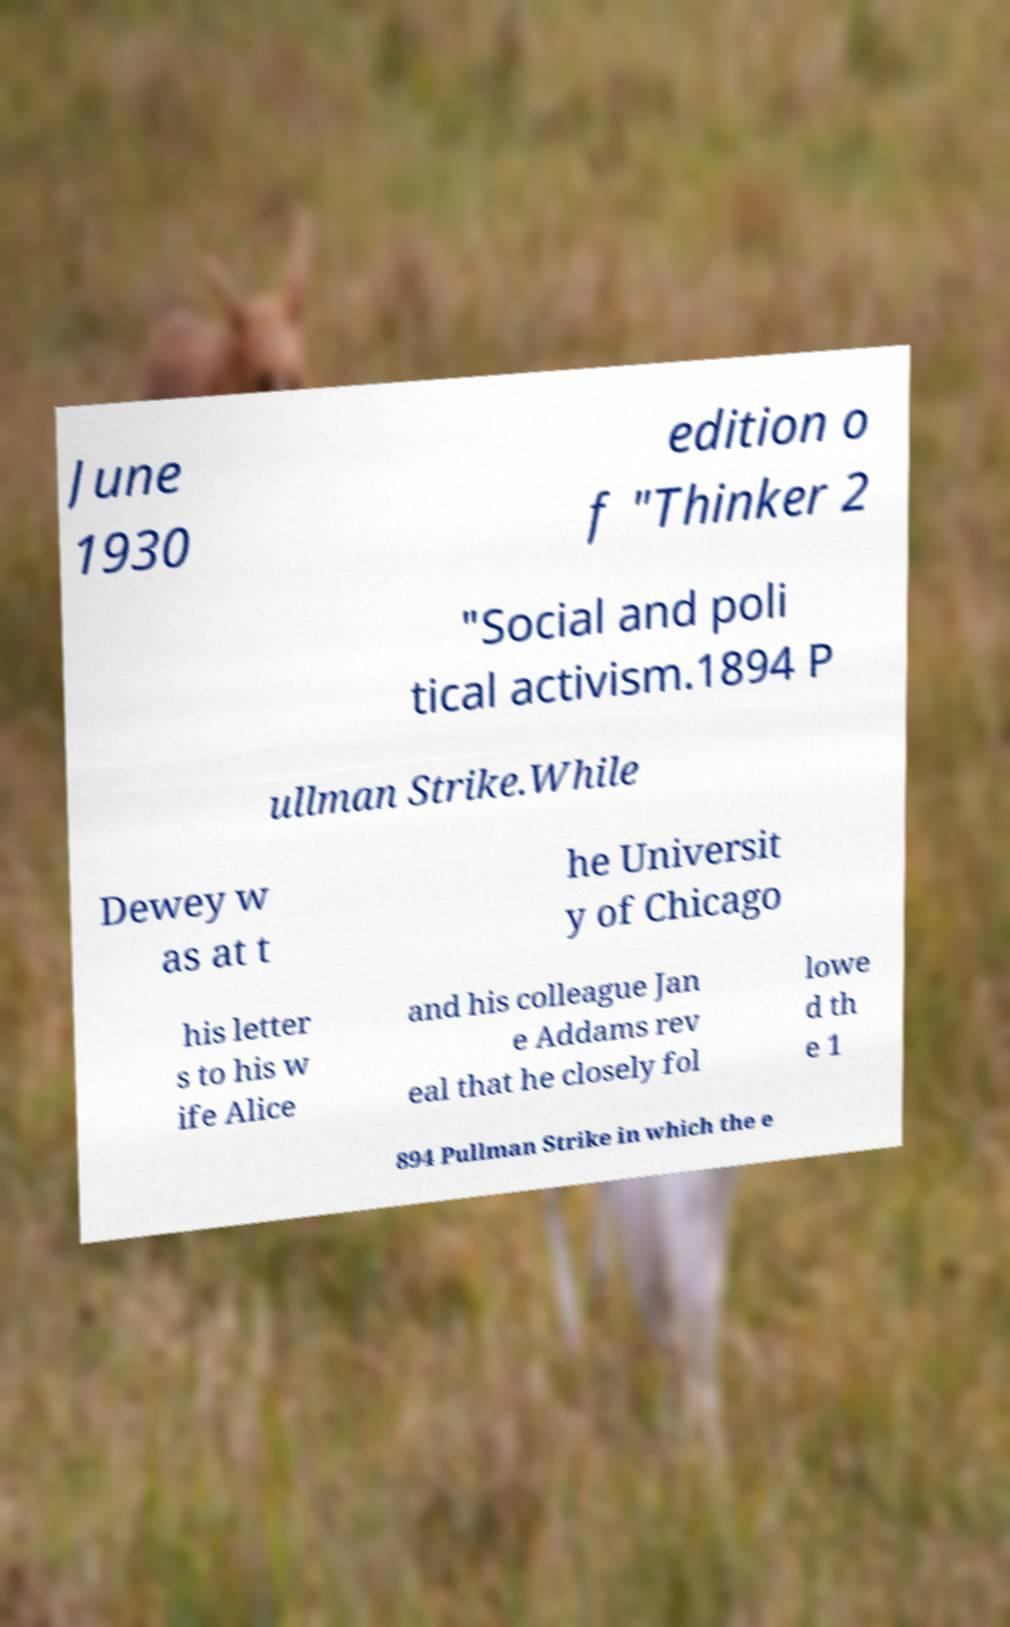Please identify and transcribe the text found in this image. June 1930 edition o f "Thinker 2 "Social and poli tical activism.1894 P ullman Strike.While Dewey w as at t he Universit y of Chicago his letter s to his w ife Alice and his colleague Jan e Addams rev eal that he closely fol lowe d th e 1 894 Pullman Strike in which the e 